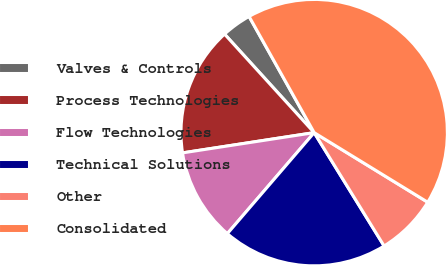<chart> <loc_0><loc_0><loc_500><loc_500><pie_chart><fcel>Valves & Controls<fcel>Process Technologies<fcel>Flow Technologies<fcel>Technical Solutions<fcel>Other<fcel>Consolidated<nl><fcel>3.62%<fcel>15.68%<fcel>11.27%<fcel>20.1%<fcel>7.45%<fcel>41.88%<nl></chart> 